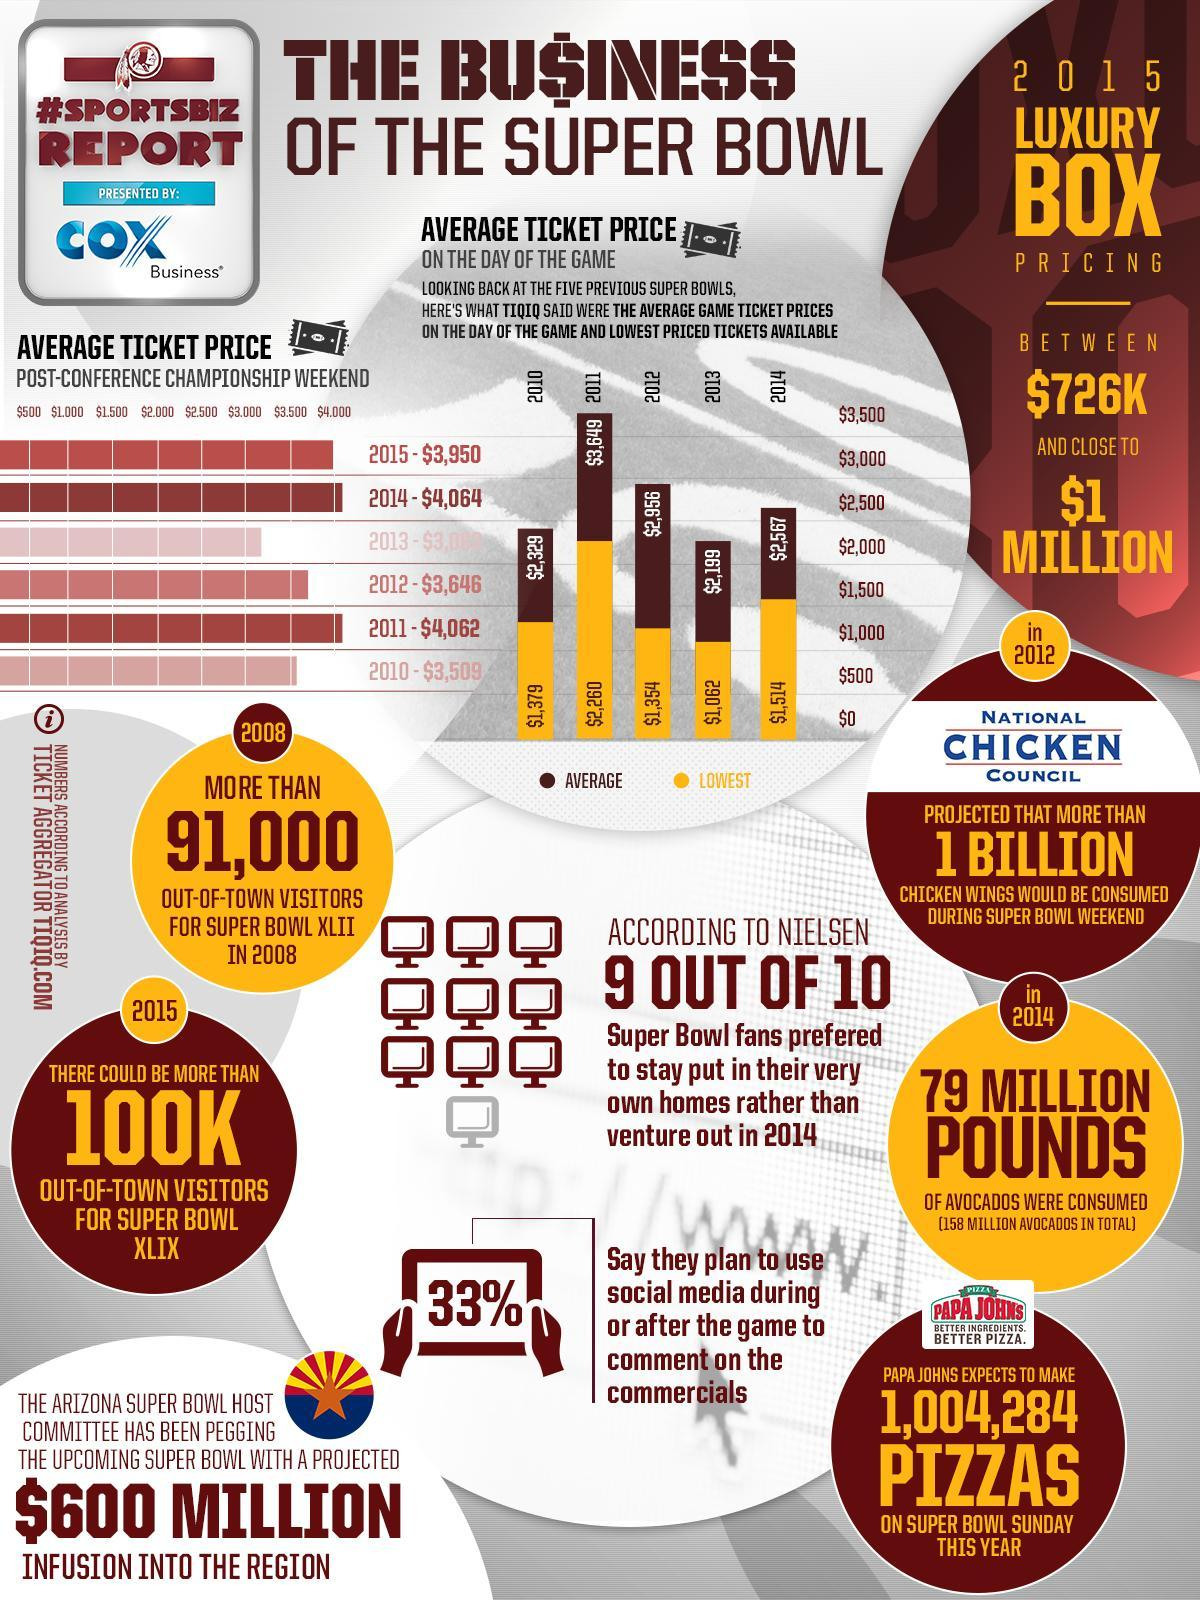How many out-of-town visitors were there for Super Bowl XLII in 2008?
Answer the question with a short phrase. MORE THAN 91,000 Which year has seen the highest average ticket price for the game among the five previous super bowls according to the ticket aggregator TIQIQ? 2011 What is the average ticket price in the post-conference Championship weekend in 2011 according to TIQIQ? $4,062 What is the lowest price ticket available for the super bowl game in 2013 according to TIQIQ? $1,062 What is the lowest price ticket available for the super bowl game in 2010 according to TIQIQ? $1,379 What is the average ticket price on the day of the Super Bowl game in 2014 according to TIQIQ? $2,567 